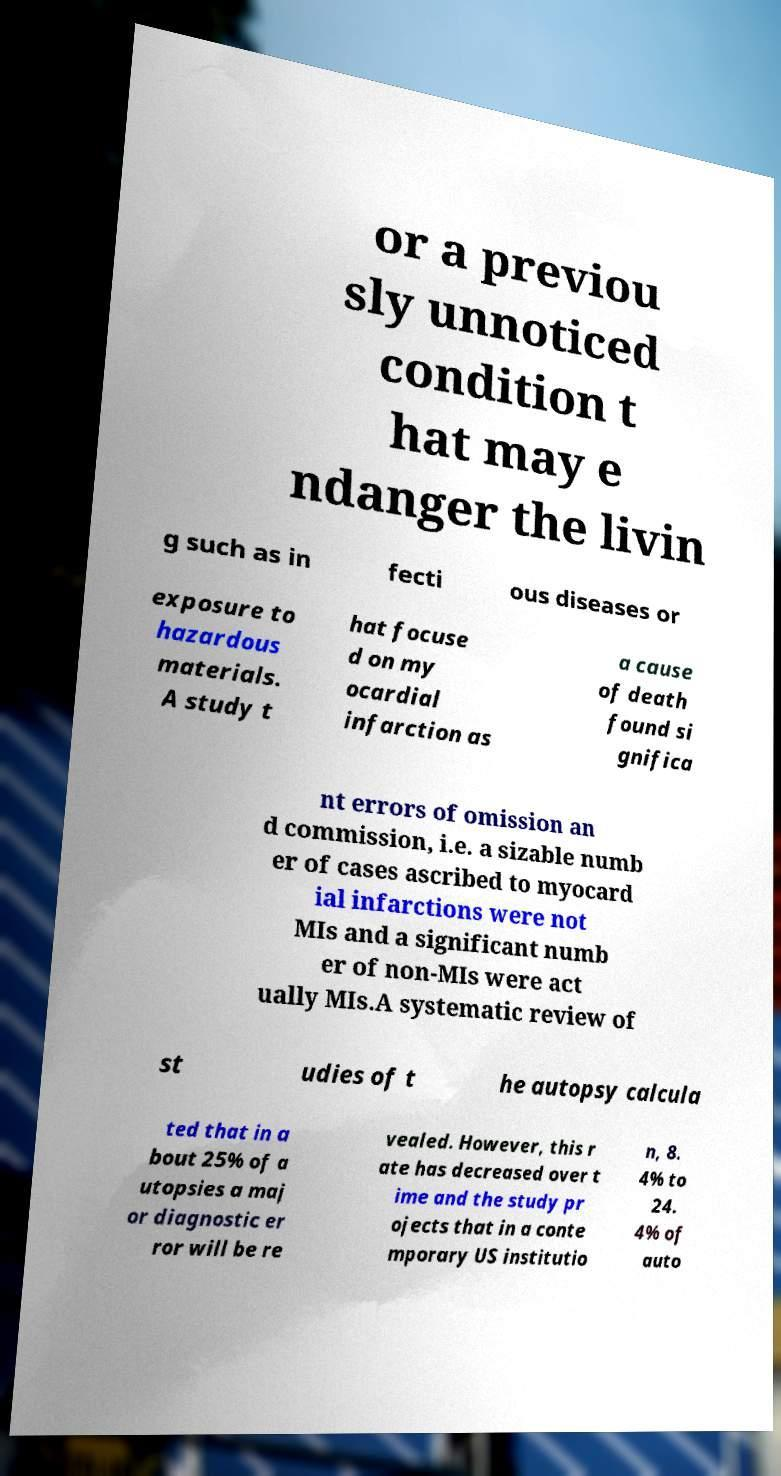Please read and relay the text visible in this image. What does it say? or a previou sly unnoticed condition t hat may e ndanger the livin g such as in fecti ous diseases or exposure to hazardous materials. A study t hat focuse d on my ocardial infarction as a cause of death found si gnifica nt errors of omission an d commission, i.e. a sizable numb er of cases ascribed to myocard ial infarctions were not MIs and a significant numb er of non-MIs were act ually MIs.A systematic review of st udies of t he autopsy calcula ted that in a bout 25% of a utopsies a maj or diagnostic er ror will be re vealed. However, this r ate has decreased over t ime and the study pr ojects that in a conte mporary US institutio n, 8. 4% to 24. 4% of auto 